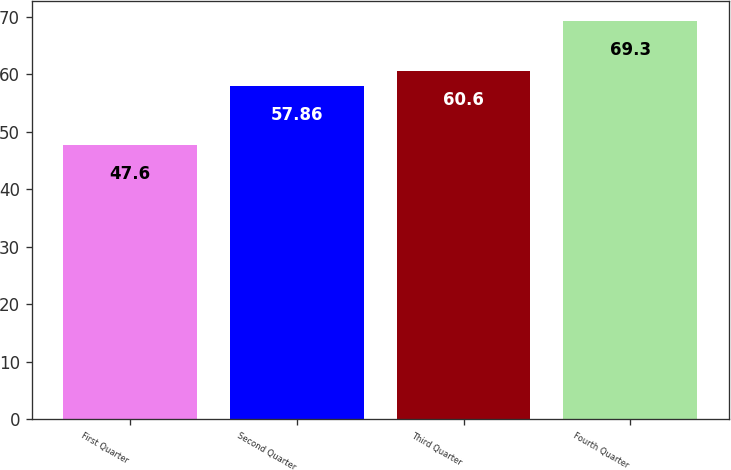Convert chart to OTSL. <chart><loc_0><loc_0><loc_500><loc_500><bar_chart><fcel>First Quarter<fcel>Second Quarter<fcel>Third Quarter<fcel>Fourth Quarter<nl><fcel>47.6<fcel>57.86<fcel>60.6<fcel>69.3<nl></chart> 